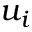<formula> <loc_0><loc_0><loc_500><loc_500>u _ { i }</formula> 